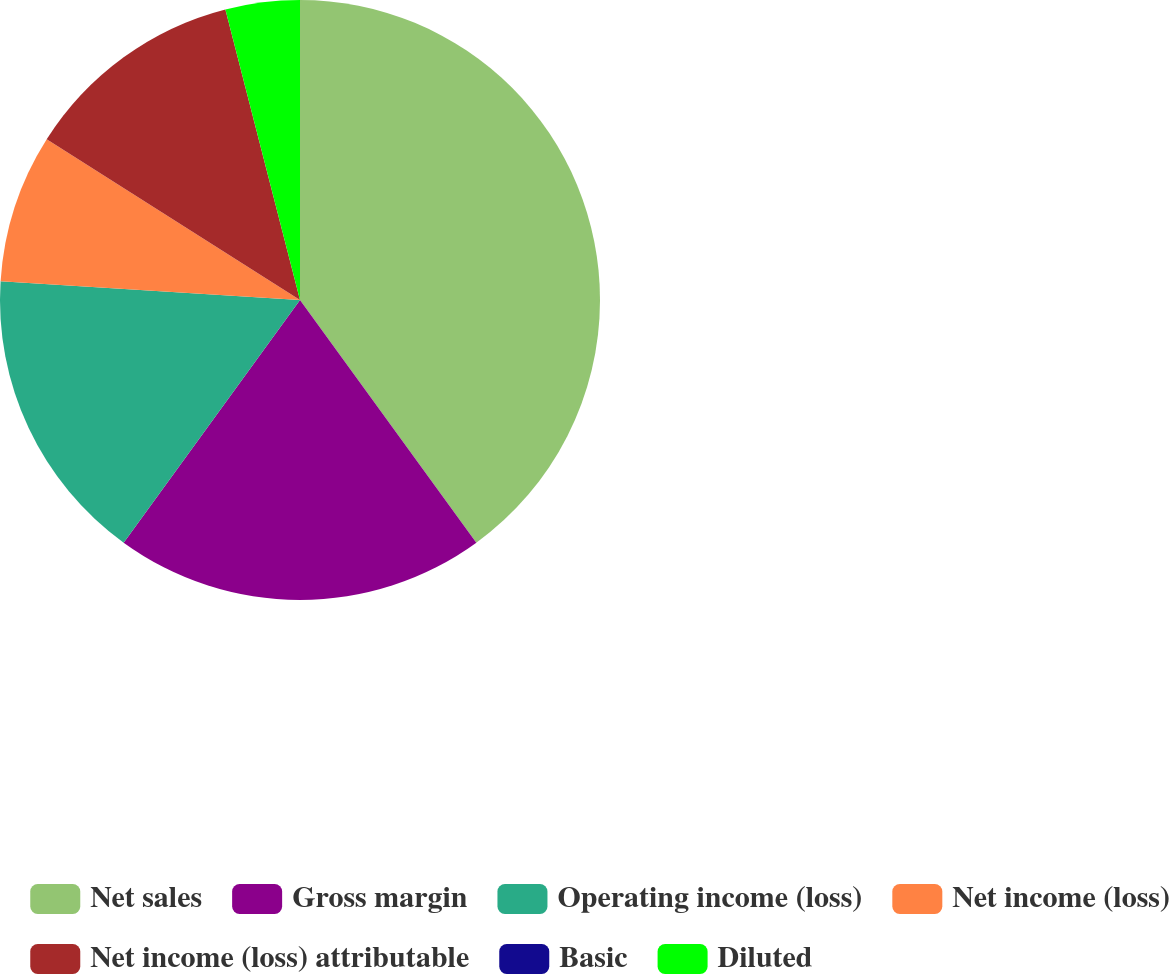Convert chart. <chart><loc_0><loc_0><loc_500><loc_500><pie_chart><fcel>Net sales<fcel>Gross margin<fcel>Operating income (loss)<fcel>Net income (loss)<fcel>Net income (loss) attributable<fcel>Basic<fcel>Diluted<nl><fcel>40.0%<fcel>20.0%<fcel>16.0%<fcel>8.0%<fcel>12.0%<fcel>0.0%<fcel>4.0%<nl></chart> 